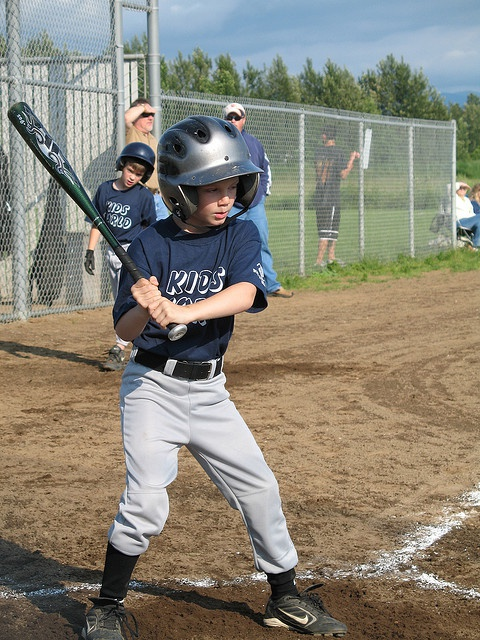Describe the objects in this image and their specific colors. I can see people in darkgray, black, lightgray, and gray tones, people in darkgray, black, darkblue, navy, and gray tones, baseball bat in darkgray, black, gray, and teal tones, people in darkgray, gray, and tan tones, and people in darkgray, gray, and lightblue tones in this image. 